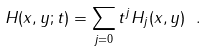<formula> <loc_0><loc_0><loc_500><loc_500>H ( x , y ; t ) = \sum _ { j = 0 } t ^ { j } H _ { j } ( x , y ) \ .</formula> 